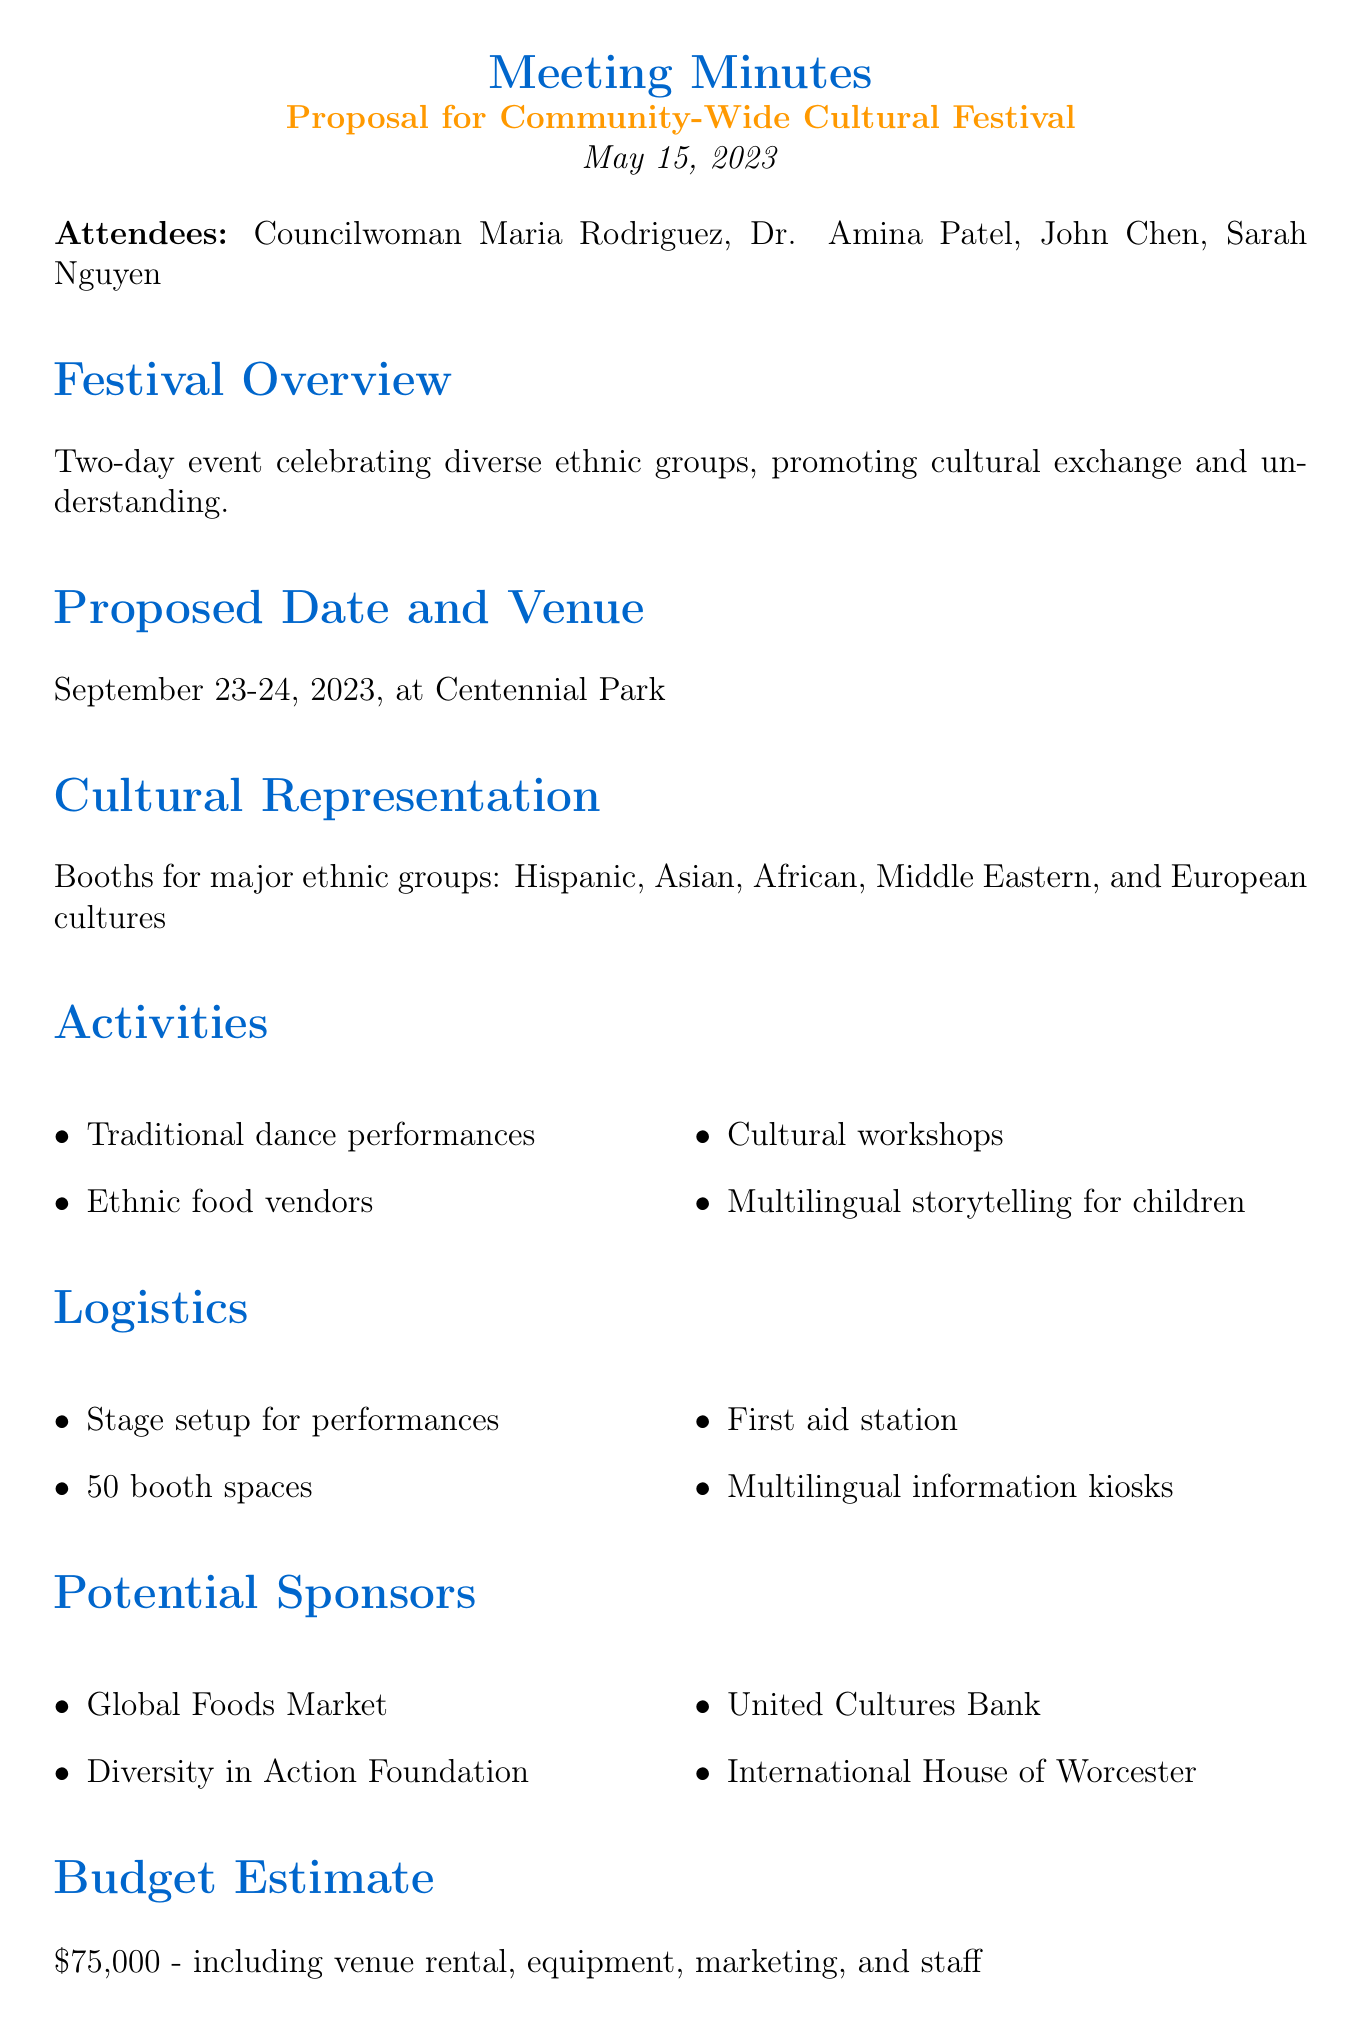What are the dates of the festival? The document states the festival will be held on September 23-24, 2023.
Answer: September 23-24, 2023 Who is the Cultural Affairs Director? The document lists Dr. Amina Patel as the Cultural Affairs Director attending the meeting.
Answer: Dr. Amina Patel How many booth spaces are planned for cultural displays? According to the logistics section, there will be 50 booth spaces for cultural displays and food vendors.
Answer: 50 What is the budget estimate for the festival? The budget estimate provided in the document is $75,000, covering multiple costs associated with the festival.
Answer: $75,000 What kind of workshops will be offered at the festival? The document mentions cultural workshops, including calligraphy and henna art as part of the activities.
Answer: Calligraphy, henna art What is one potential sponsor mentioned? The document lists several potential sponsors, including the Global Foods Market as one of them.
Answer: Global Foods Market What is the first step listed in the next steps? The document outlines that forming a diverse planning committee is the first step in the next steps section.
Answer: Form a diverse planning committee Which park will host the festival? The proposed venue for the festival mentioned in the document is Centennial Park.
Answer: Centennial Park How will the festival promote diversity? The festival aims to celebrate various ethnic groups and promote cultural exchange and understanding.
Answer: Cultural exchange and understanding 